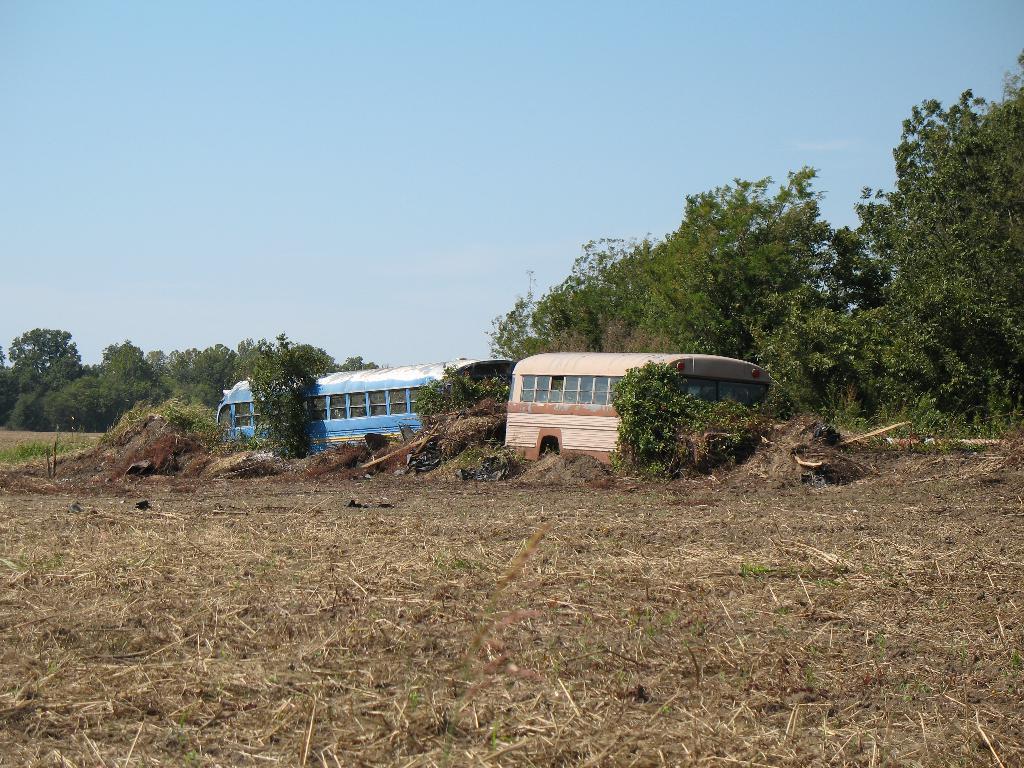Can you describe this image briefly? In this image we can see two buses which are of different colors are parked in an open area and at the background of the image there are some trees and clear sky. 